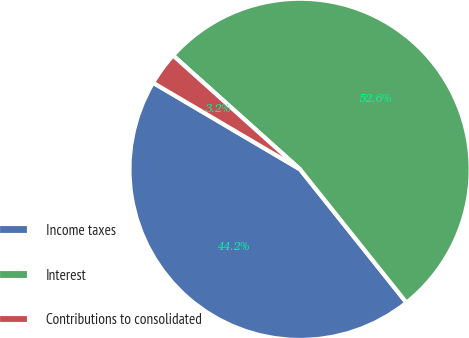Convert chart. <chart><loc_0><loc_0><loc_500><loc_500><pie_chart><fcel>Income taxes<fcel>Interest<fcel>Contributions to consolidated<nl><fcel>44.19%<fcel>52.64%<fcel>3.16%<nl></chart> 